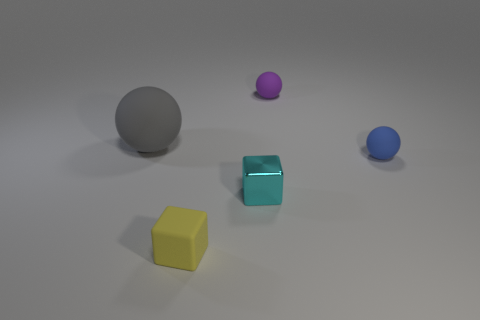Add 2 small yellow rubber objects. How many objects exist? 7 Subtract all blocks. How many objects are left? 3 Add 3 gray metallic things. How many gray metallic things exist? 3 Subtract 0 purple blocks. How many objects are left? 5 Subtract all large gray objects. Subtract all tiny purple balls. How many objects are left? 3 Add 5 purple things. How many purple things are left? 6 